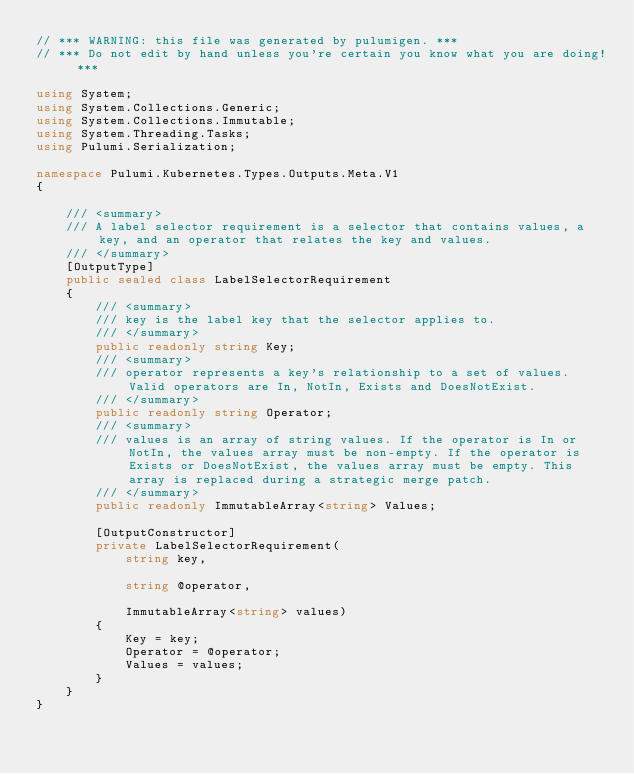<code> <loc_0><loc_0><loc_500><loc_500><_C#_>// *** WARNING: this file was generated by pulumigen. ***
// *** Do not edit by hand unless you're certain you know what you are doing! ***

using System;
using System.Collections.Generic;
using System.Collections.Immutable;
using System.Threading.Tasks;
using Pulumi.Serialization;

namespace Pulumi.Kubernetes.Types.Outputs.Meta.V1
{

    /// <summary>
    /// A label selector requirement is a selector that contains values, a key, and an operator that relates the key and values.
    /// </summary>
    [OutputType]
    public sealed class LabelSelectorRequirement
    {
        /// <summary>
        /// key is the label key that the selector applies to.
        /// </summary>
        public readonly string Key;
        /// <summary>
        /// operator represents a key's relationship to a set of values. Valid operators are In, NotIn, Exists and DoesNotExist.
        /// </summary>
        public readonly string Operator;
        /// <summary>
        /// values is an array of string values. If the operator is In or NotIn, the values array must be non-empty. If the operator is Exists or DoesNotExist, the values array must be empty. This array is replaced during a strategic merge patch.
        /// </summary>
        public readonly ImmutableArray<string> Values;

        [OutputConstructor]
        private LabelSelectorRequirement(
            string key,

            string @operator,

            ImmutableArray<string> values)
        {
            Key = key;
            Operator = @operator;
            Values = values;
        }
    }
}
</code> 